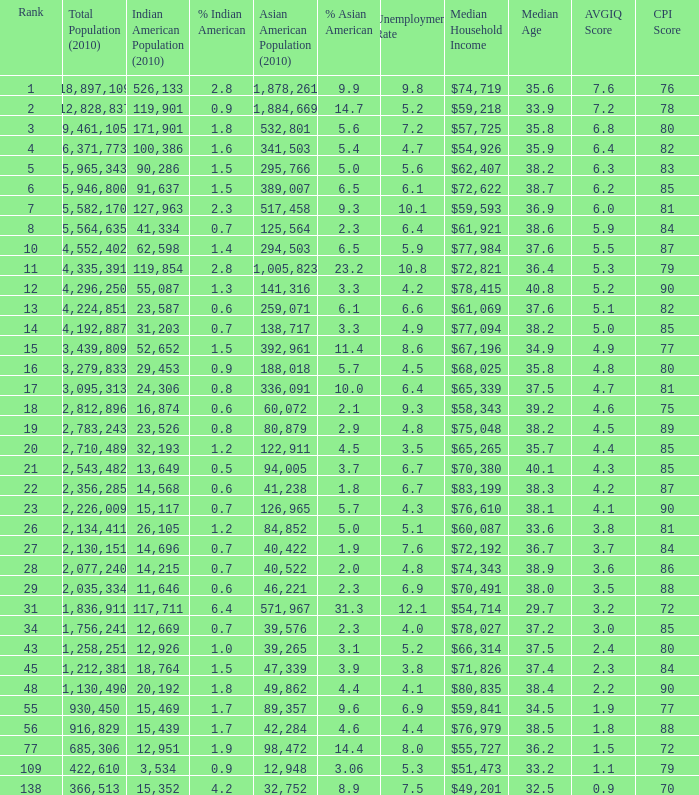What's the total population when there are 5.7% Asian American and fewer than 126,965 Asian American Population? None. 